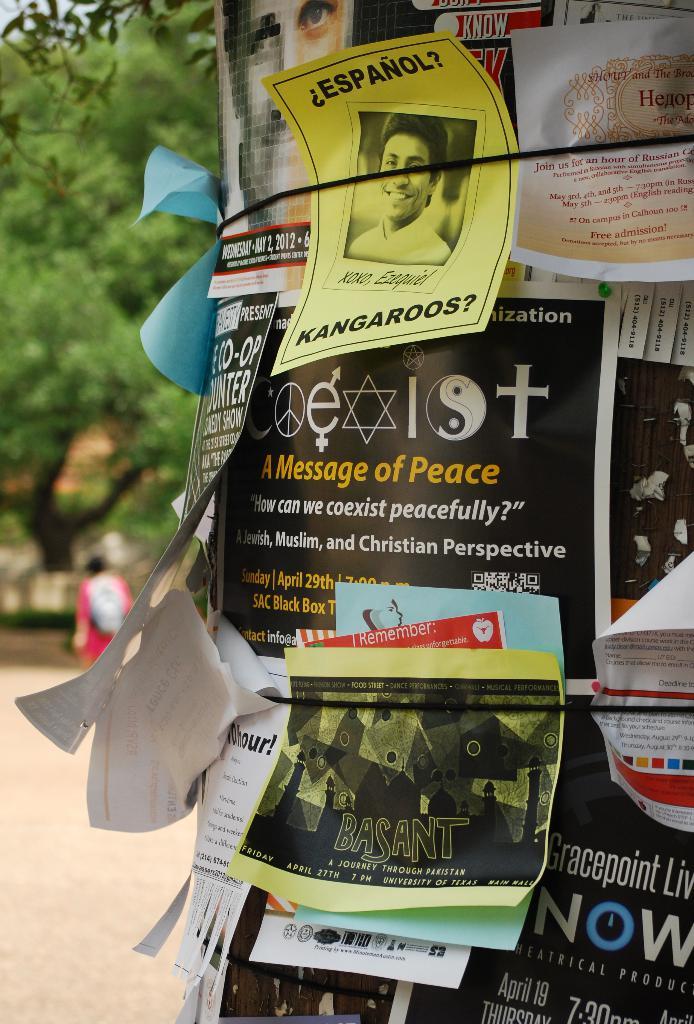Coexist brings a message of what?
Provide a short and direct response. Peace. What is the animal written on the yellow paper?
Your answer should be compact. Kangaroos. 